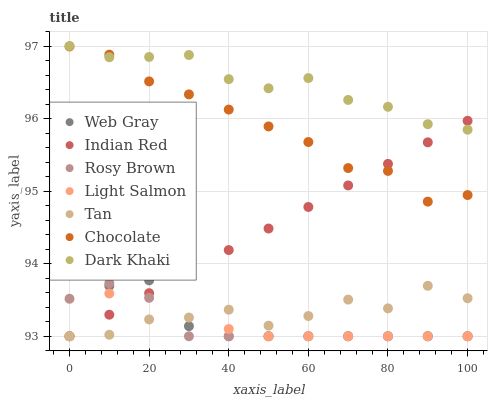Does Rosy Brown have the minimum area under the curve?
Answer yes or no. Yes. Does Dark Khaki have the maximum area under the curve?
Answer yes or no. Yes. Does Web Gray have the minimum area under the curve?
Answer yes or no. No. Does Web Gray have the maximum area under the curve?
Answer yes or no. No. Is Indian Red the smoothest?
Answer yes or no. Yes. Is Tan the roughest?
Answer yes or no. Yes. Is Web Gray the smoothest?
Answer yes or no. No. Is Web Gray the roughest?
Answer yes or no. No. Does Light Salmon have the lowest value?
Answer yes or no. Yes. Does Chocolate have the lowest value?
Answer yes or no. No. Does Dark Khaki have the highest value?
Answer yes or no. Yes. Does Web Gray have the highest value?
Answer yes or no. No. Is Rosy Brown less than Chocolate?
Answer yes or no. Yes. Is Dark Khaki greater than Rosy Brown?
Answer yes or no. Yes. Does Web Gray intersect Rosy Brown?
Answer yes or no. Yes. Is Web Gray less than Rosy Brown?
Answer yes or no. No. Is Web Gray greater than Rosy Brown?
Answer yes or no. No. Does Rosy Brown intersect Chocolate?
Answer yes or no. No. 